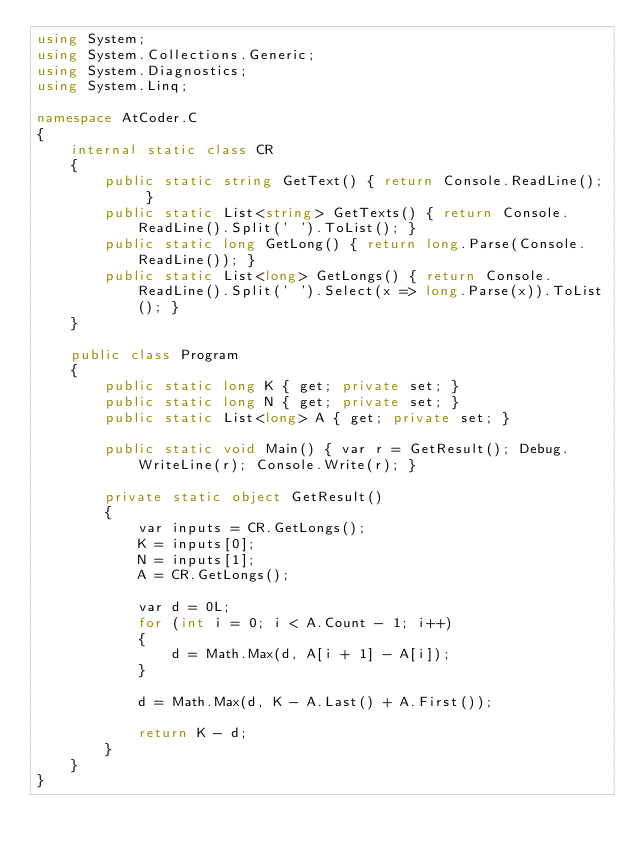<code> <loc_0><loc_0><loc_500><loc_500><_C#_>using System;
using System.Collections.Generic;
using System.Diagnostics;
using System.Linq;

namespace AtCoder.C
{
    internal static class CR
    {
        public static string GetText() { return Console.ReadLine(); }
        public static List<string> GetTexts() { return Console.ReadLine().Split(' ').ToList(); }
        public static long GetLong() { return long.Parse(Console.ReadLine()); }
        public static List<long> GetLongs() { return Console.ReadLine().Split(' ').Select(x => long.Parse(x)).ToList(); }
    }

    public class Program
    {
        public static long K { get; private set; }
        public static long N { get; private set; }
        public static List<long> A { get; private set; }

        public static void Main() { var r = GetResult(); Debug.WriteLine(r); Console.Write(r); }

        private static object GetResult()
        {
            var inputs = CR.GetLongs();
            K = inputs[0];
            N = inputs[1];
            A = CR.GetLongs();

            var d = 0L;
            for (int i = 0; i < A.Count - 1; i++)
            {
                d = Math.Max(d, A[i + 1] - A[i]);
            }

            d = Math.Max(d, K - A.Last() + A.First());

            return K - d;
        }
    }
}
</code> 